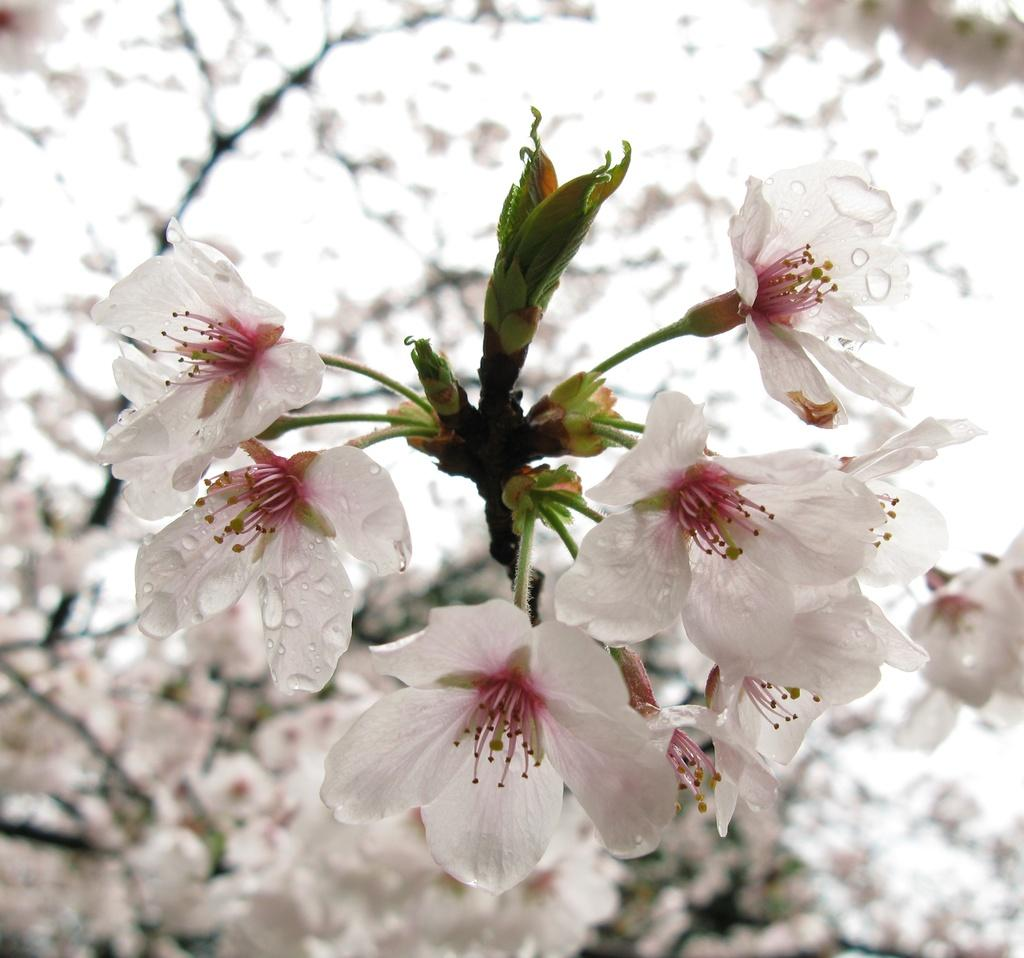What type of living organisms can be seen in the image? There are flowers in the image. Can you describe the background of the image? The background of the image is blurred. What type of pump can be seen in the image? There is no pump present in the image. What type of yak can be seen grazing in the background of the image? There is no yak present in the image, and the background is blurred, not showing any specific animals or objects. 